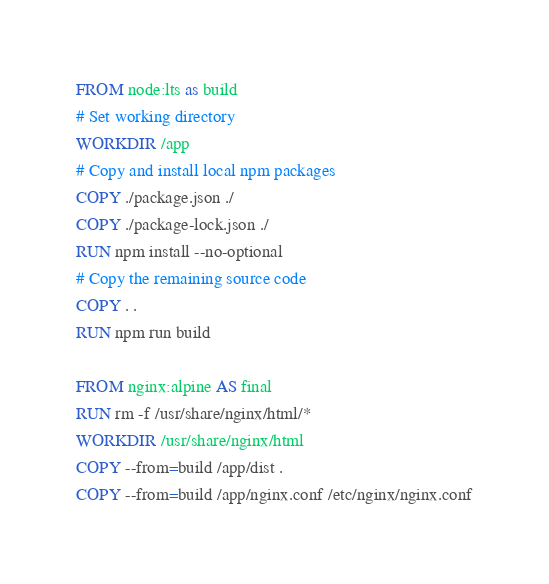Convert code to text. <code><loc_0><loc_0><loc_500><loc_500><_Dockerfile_>FROM node:lts as build
# Set working directory
WORKDIR /app
# Copy and install local npm packages
COPY ./package.json ./
COPY ./package-lock.json ./
RUN npm install --no-optional
# Copy the remaining source code
COPY . .
RUN npm run build

FROM nginx:alpine AS final
RUN rm -f /usr/share/nginx/html/*
WORKDIR /usr/share/nginx/html
COPY --from=build /app/dist .
COPY --from=build /app/nginx.conf /etc/nginx/nginx.conf
</code> 